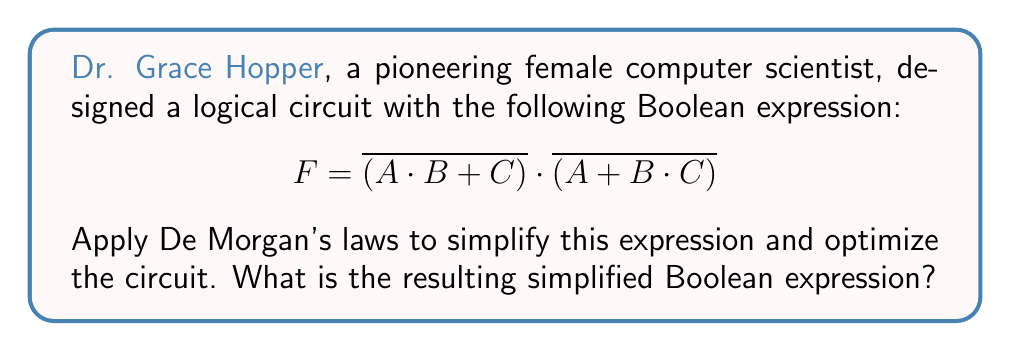Solve this math problem. Let's simplify the expression step by step using De Morgan's laws:

1) First, apply De Morgan's law to each term separately:

   $F = \overline{(A \cdot B + C)} \cdot \overline{(A + B \cdot C)}$
   
   For the first term: $\overline{(A \cdot B + C)} = \overline{A \cdot B} \cdot \overline{C}$
   For the second term: $\overline{(A + B \cdot C)} = \overline{A} \cdot \overline{B \cdot C}$

2) Now our expression looks like:

   $F = (\overline{A \cdot B} \cdot \overline{C}) \cdot (\overline{A} \cdot \overline{B \cdot C})$

3) Apply De Morgan's law again to $\overline{A \cdot B}$ and $\overline{B \cdot C}$:

   $\overline{A \cdot B} = \overline{A} + \overline{B}$
   $\overline{B \cdot C} = \overline{B} + \overline{C}$

4) Substituting these back:

   $F = ((\overline{A} + \overline{B}) \cdot \overline{C}) \cdot (\overline{A} \cdot (\overline{B} + \overline{C}))$

5) Distribute $\overline{C}$ in the first parenthesis and $\overline{A}$ in the second:

   $F = (\overline{A} \cdot \overline{C} + \overline{B} \cdot \overline{C}) \cdot (\overline{A} \cdot \overline{B} + \overline{A} \cdot \overline{C})$

6) Now, distribute the terms:

   $F = (\overline{A} \cdot \overline{C} \cdot \overline{A} \cdot \overline{B}) + (\overline{A} \cdot \overline{C} \cdot \overline{A} \cdot \overline{C}) + (\overline{B} \cdot \overline{C} \cdot \overline{A} \cdot \overline{B}) + (\overline{B} \cdot \overline{C} \cdot \overline{A} \cdot \overline{C})$

7) Simplify by removing redundant terms:

   $F = (\overline{A} \cdot \overline{B} \cdot \overline{C}) + (\overline{A} \cdot \overline{B} \cdot \overline{C}) + (\overline{A} \cdot \overline{B} \cdot \overline{C}) + (\overline{A} \cdot \overline{B} \cdot \overline{C})$

8) All terms are identical, so we can simplify to:

   $F = \overline{A} \cdot \overline{B} \cdot \overline{C}$

This is the most simplified form of the expression.
Answer: $F = \overline{A} \cdot \overline{B} \cdot \overline{C}$ 